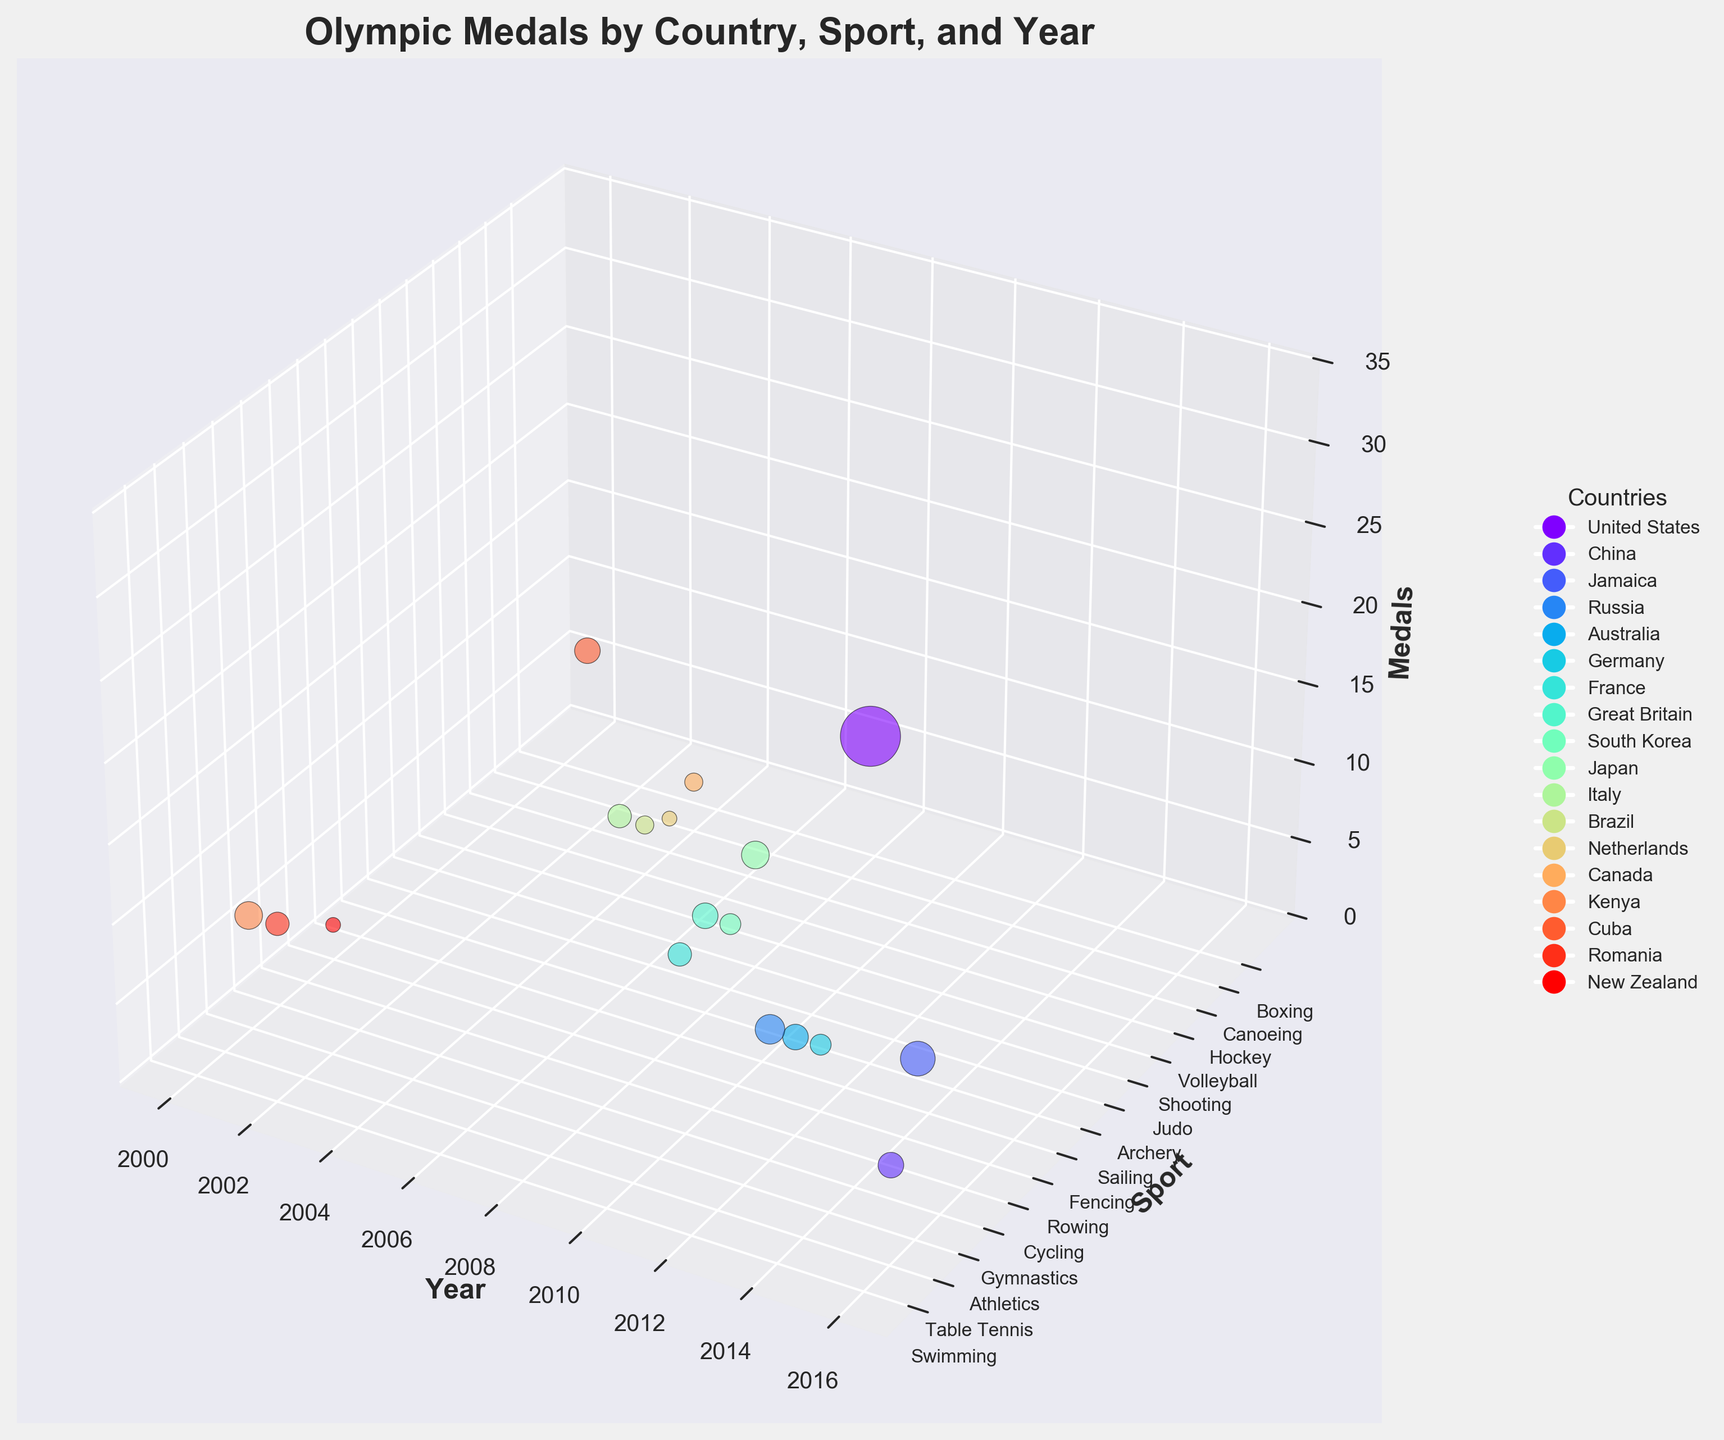How many medals did the United States win in Swimming in 2016? Find the bubble representing the United States in Swimming for 2016 and check its size or the label indicating medal count.
Answer: 33 Which year had New Zealand winning medals in Rowing? Identify the bubble for New Zealand in Rowing and check its position along the Year axis.
Answer: 2000 Compare the medals won by China in 2016 Table Tennis and Cuba in 2000 Boxing. Which country won more? Locate the bubbles for China in 2016 Table Tennis and Cuba in 2000 Boxing, then compare their sizes or the medal counts directly.
Answer: China What is the total number of medals won by Great Britain in 2008 and France in 2008? Find the bubbles for Great Britain and France in 2008, read their medal counts (6 and 5 respectively), then sum them.
Answer: 11 Which country won the most medals in Athletics in 2016? Compare the bubbles for countries competing in Athletics in 2016, looking at the highest bubble (Jamaica with 11 medals).
Answer: Jamaica What is the average number of medals won by the countries listed in 2004? Identify all bubbles for 2004, sum their medal counts (5 + 3 + 2 + 3 = 13), then divide by the number of countries (4).
Answer: 3.25 Between the years 2012 and 2016, did Russia win more medals in Gymnastics or did the United States win more medals in Swimming? Compare the bubble sizes for Russia in 2012 Gymnastics (8) and the United States in 2016 Swimming (33).
Answer: United States Which country has the smallest bubble across all Sports and Years? Find the smallest-size bubble in the plot (New Zealand in Rowing, 2000 with 2 medals).
Answer: New Zealand 